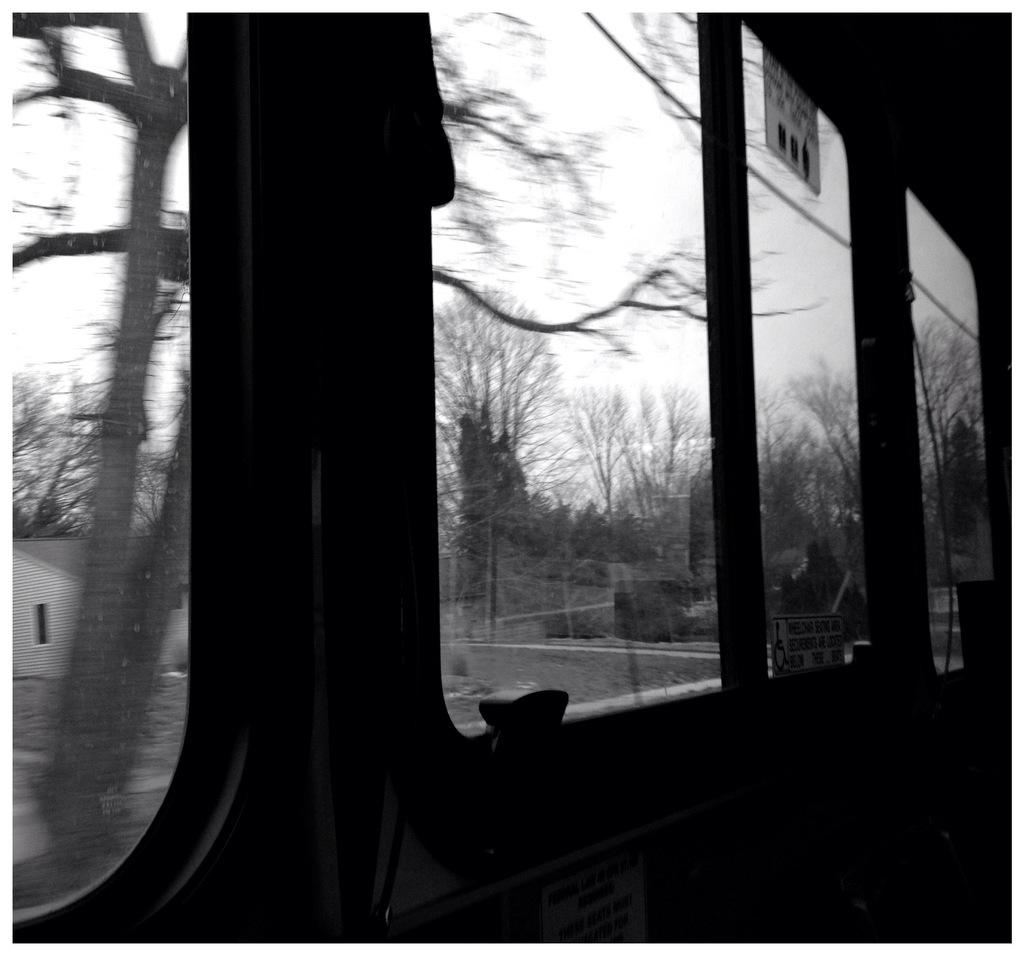What type of space is shown in the image? The image shows the interior of a vehicle. What can be seen through the windows in the image? There are glass windows visible in the image, and trees can be seen through them. What structure is visible in the image? There is a house in the image. What is the color scheme of the image? The image is in black and white. What type of flower is growing on the base of the vehicle in the image? There is no flower or base present in the image; it shows the interior of a vehicle with glass windows, trees, and a house. 